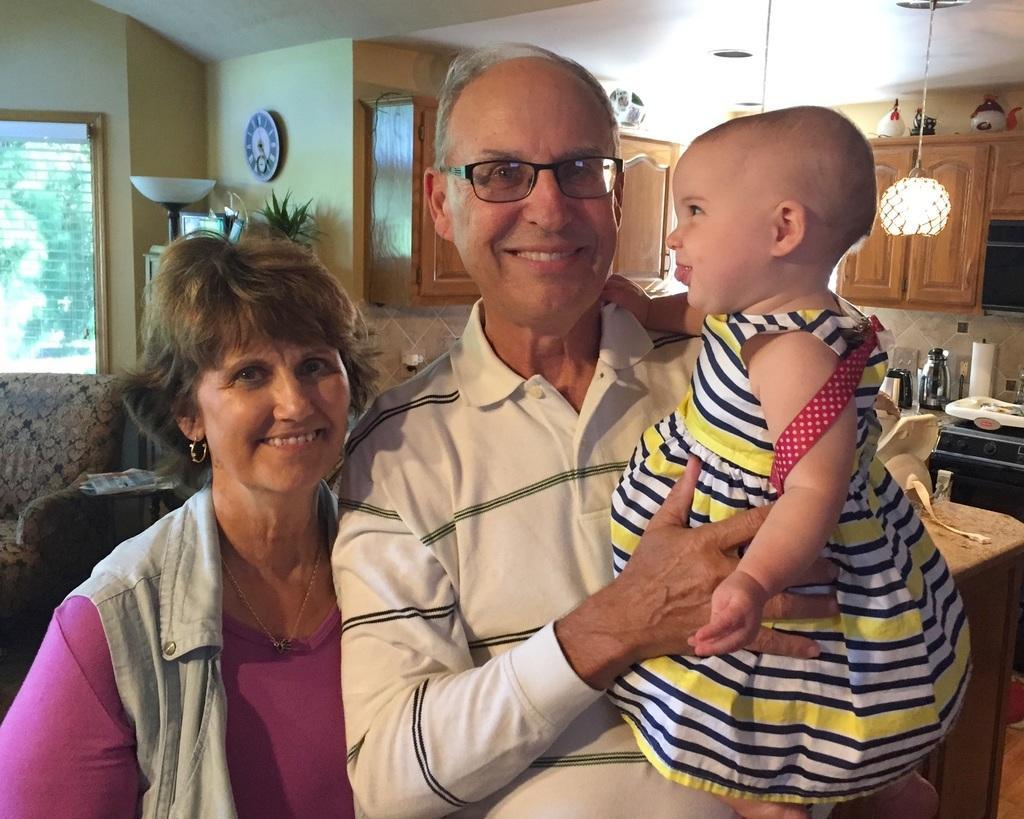How would you summarize this image in a sentence or two? In the image in the center, we can see two persons are standing and they are smiling, which we can see on their faces. And the man is holding one baby. In the background there is a wall, roof, window, wall clock, cupboards, lights, sofas, tables, flasks, containers and a few other objects. 